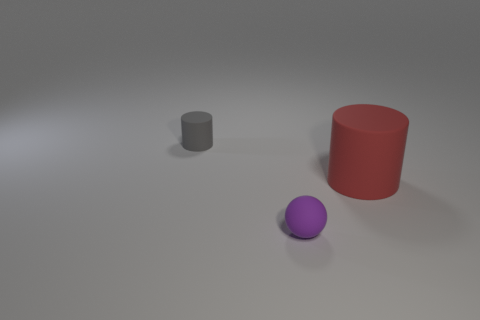Add 3 red matte cylinders. How many objects exist? 6 Subtract all red cylinders. How many cylinders are left? 1 Subtract 1 spheres. How many spheres are left? 0 Add 3 red matte things. How many red matte things are left? 4 Add 2 small purple matte spheres. How many small purple matte spheres exist? 3 Subtract 1 purple balls. How many objects are left? 2 Subtract all spheres. How many objects are left? 2 Subtract all gray cylinders. Subtract all gray blocks. How many cylinders are left? 1 Subtract all red balls. How many purple cylinders are left? 0 Subtract all big green matte cubes. Subtract all tiny gray cylinders. How many objects are left? 2 